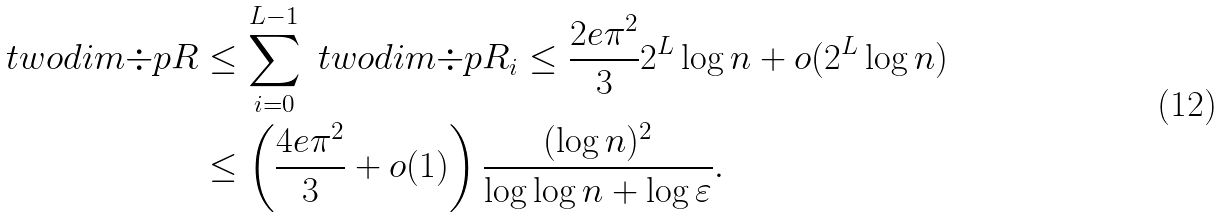<formula> <loc_0><loc_0><loc_500><loc_500>\ t w o d i m { \div p { R } } & \leq \sum _ { i = 0 } ^ { L - 1 } \ t w o d i m { \div p { R _ { i } } } \leq \frac { 2 e \pi ^ { 2 } } { 3 } 2 ^ { L } \log n + o ( 2 ^ { L } \log n ) \\ & \leq \left ( \frac { 4 e \pi ^ { 2 } } { 3 } + o ( 1 ) \right ) \frac { ( \log n ) ^ { 2 } } { \log \log n + \log \varepsilon } .</formula> 